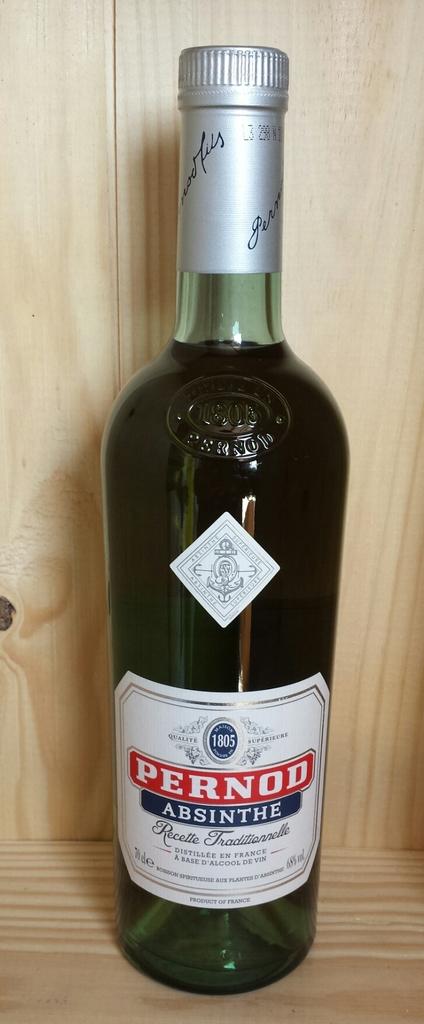What is the brand name?
Keep it short and to the point. Pernod. 